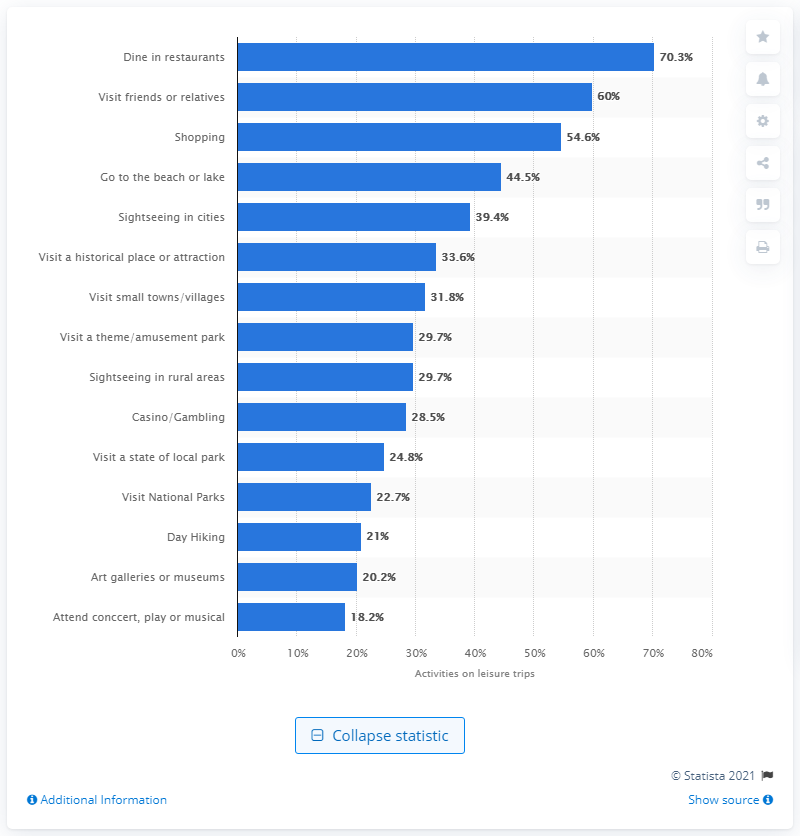How does the popularity of sightseeing in cities compare to visiting national parks? Sightseeing in cities is more popular, with 39.4% of leisure trip travellers enjoying this activity, while visiting national parks draws 22.7%, making it less popular by comparison. 